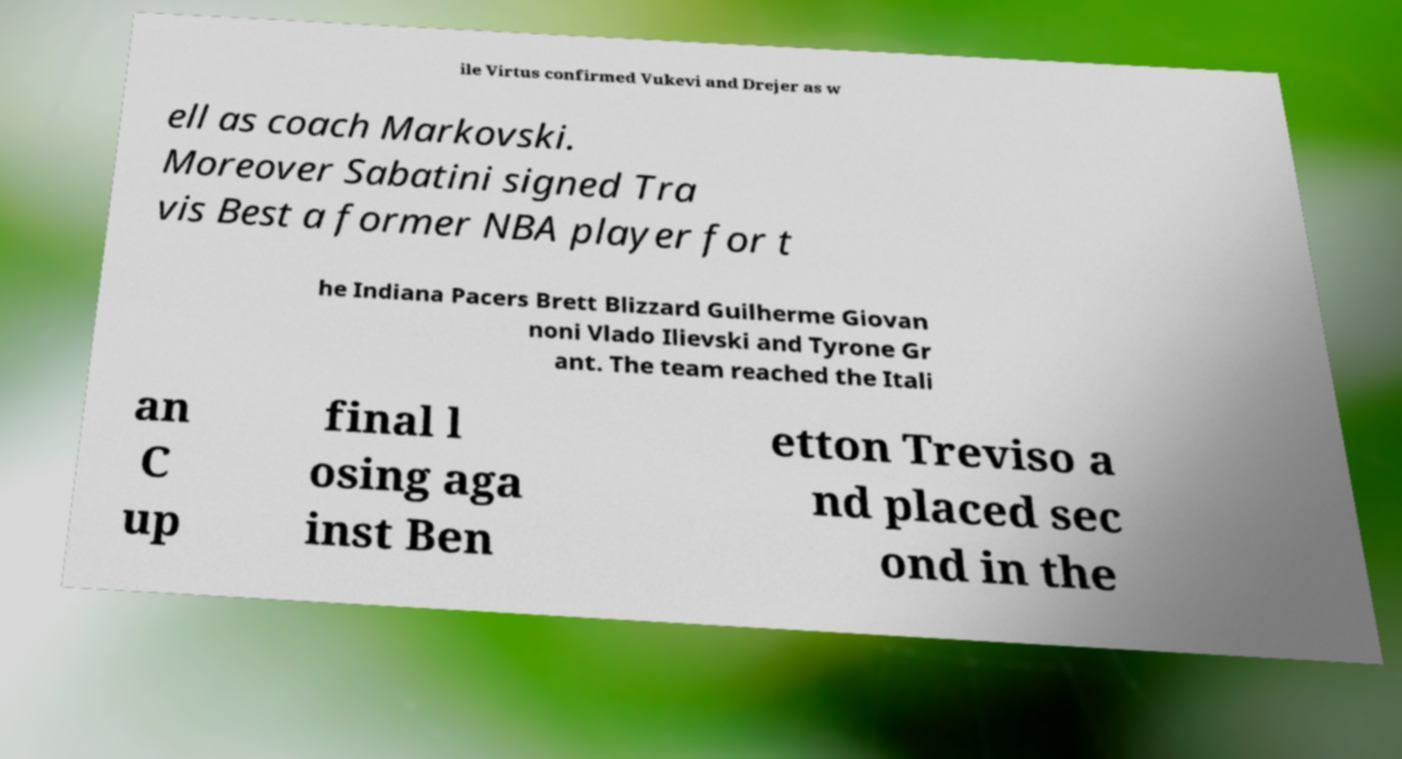For documentation purposes, I need the text within this image transcribed. Could you provide that? ile Virtus confirmed Vukevi and Drejer as w ell as coach Markovski. Moreover Sabatini signed Tra vis Best a former NBA player for t he Indiana Pacers Brett Blizzard Guilherme Giovan noni Vlado Ilievski and Tyrone Gr ant. The team reached the Itali an C up final l osing aga inst Ben etton Treviso a nd placed sec ond in the 